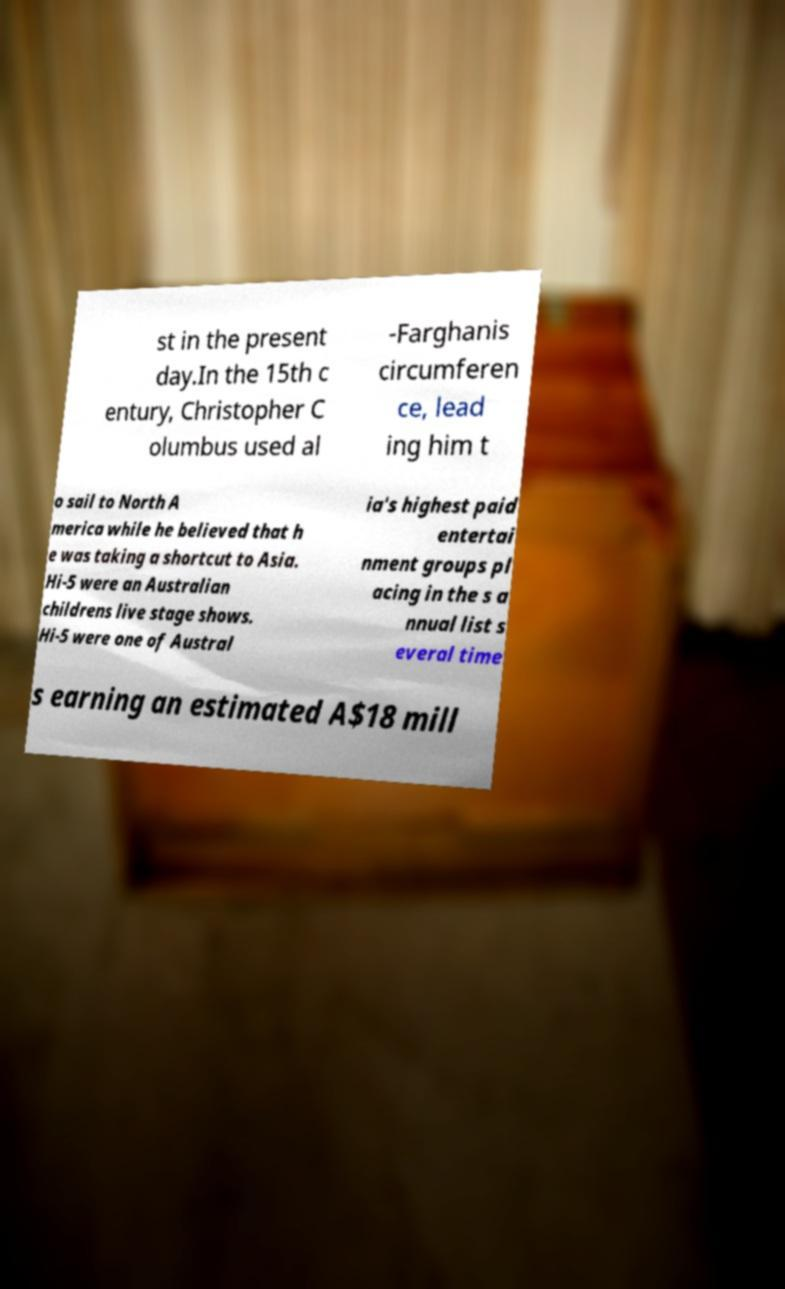Can you read and provide the text displayed in the image?This photo seems to have some interesting text. Can you extract and type it out for me? st in the present day.In the 15th c entury, Christopher C olumbus used al -Farghanis circumferen ce, lead ing him t o sail to North A merica while he believed that h e was taking a shortcut to Asia. Hi-5 were an Australian childrens live stage shows. Hi-5 were one of Austral ia's highest paid entertai nment groups pl acing in the s a nnual list s everal time s earning an estimated A$18 mill 